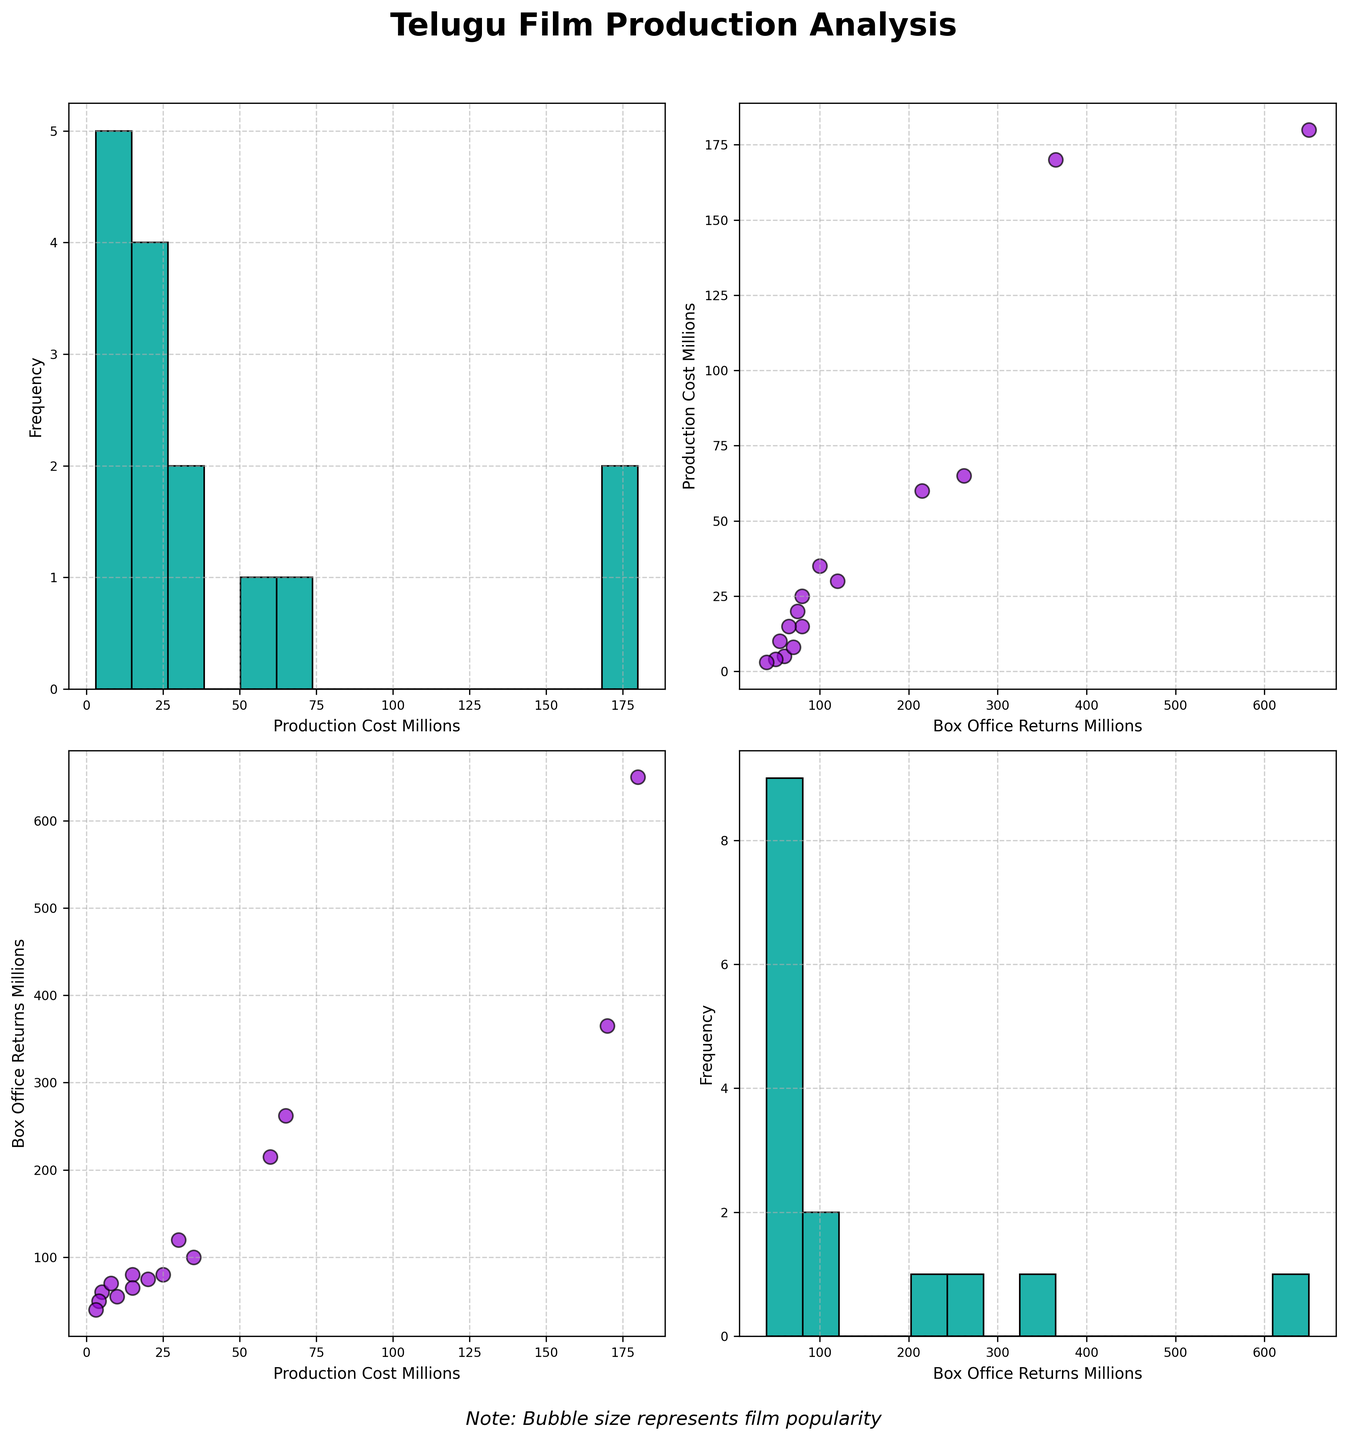How many different scatter plots and histograms are displayed in the scatterplot matrix? Each combination of two different numerical columns produces a scatter plot. Since there are two numerical columns, `Production Cost` and `Box Office Returns`, there is 1 scatter plot (`x = Production Cost, y = Box Office Returns`) and 1 histogram for each variable. Therefore, there are 4 plots in total (2 scatter plots + 2 histograms).
Answer: 4 plots Which variable has the highest frequency of values around the lower end in its histogram? To determine this, you observe the histograms on the diagonal of the scatterplot matrix. Visually, the histogram of `Production Cost` shows more film counts towards the lower end (between 0 and 50 million) compared to `Box Office Returns`, which has fewer films clustered at the lowest end.
Answer: Production Cost What is the approximate range of `Box Office Returns` values in the scatterplot? By examining the x-axis of the scatter plots involving `Box Office Returns`, we can see the values range approximately from 40 to 650 million.
Answer: 40 to 650 million How does `Box Office Returns` generally trend with increasing `Production Cost`? In the scatter plot with `Box Office Returns` on the y-axis and `Production Cost` on the x-axis, we can see that as `Production Cost` increases, `Box Office Returns` also tend to increase.
Answer: Increasing trend Which film could likely be the data point with the highest `Production Cost` and `Box Office Returns`? Referring to the scatter plots, the highest `Production Cost` is near 180 million while the highest `Box Office Returns` is around 650 million. This combination indicates the film is likely `Baahubali: The Beginning`.
Answer: Baahubali: The Beginning Are there any films with low `Production Cost` (under 10 million) that nevertheless achieved high `Box Office Returns`? By looking at the scatter plot with `Production Cost` and `Box Office Returns`, data points in the low-cost region (under 10 million) and relatively high returns (over 50 million) include films like `Premam` and `Arjun Reddy`.
Answer: Premam, Arjun Reddy Which films have `Production Costs` near the median value? To find films around the median value, identify the middle point of the `Production Cost` histogram distribution. The middle value visually appears around 25 million. Films with `Production Costs` near 25 million include `Jersey` and `Karthikeya 2`.
Answer: Jersey, Karthikeya 2 Do any films significantly deviate from the general trend of increasing `Box Office Returns` with higher `Production Costs`? Checking the scatter plots for outliers, most films generally follow the trend. However, `RX 100` and `Premam` had lower production costs (< 10 million) and relatively high returns. Conversely, `Sita Ramam` had a higher production cost but relatively moderate returns.
Answer: RX 100, Premam, Sita Ramam 